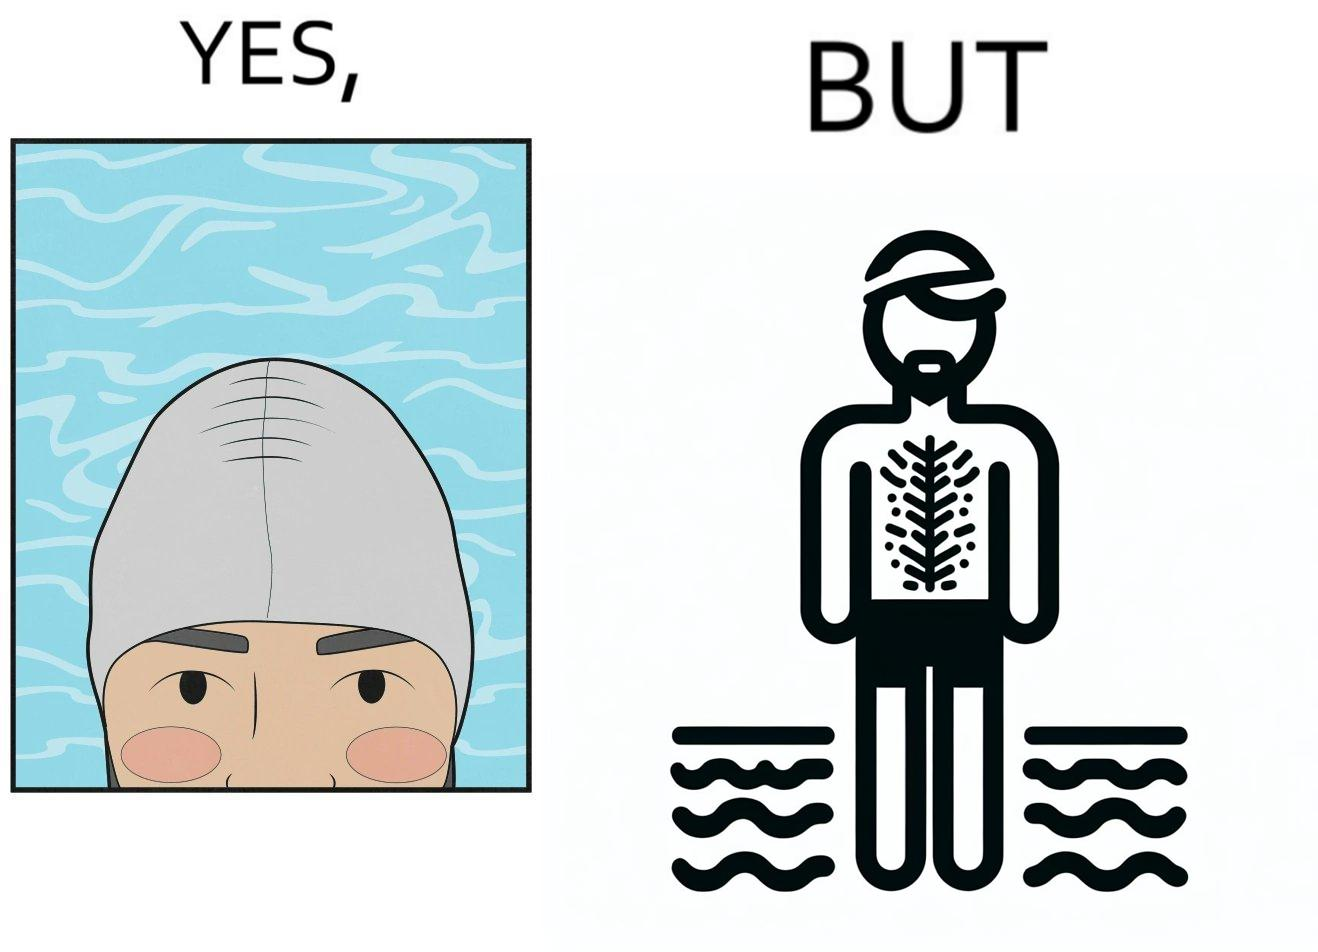Why is this image considered satirical? The man is wearing a swimming cap to protect his head's hair but on the other side he is not concerned over the hair all over his body and is nowhere covering them 